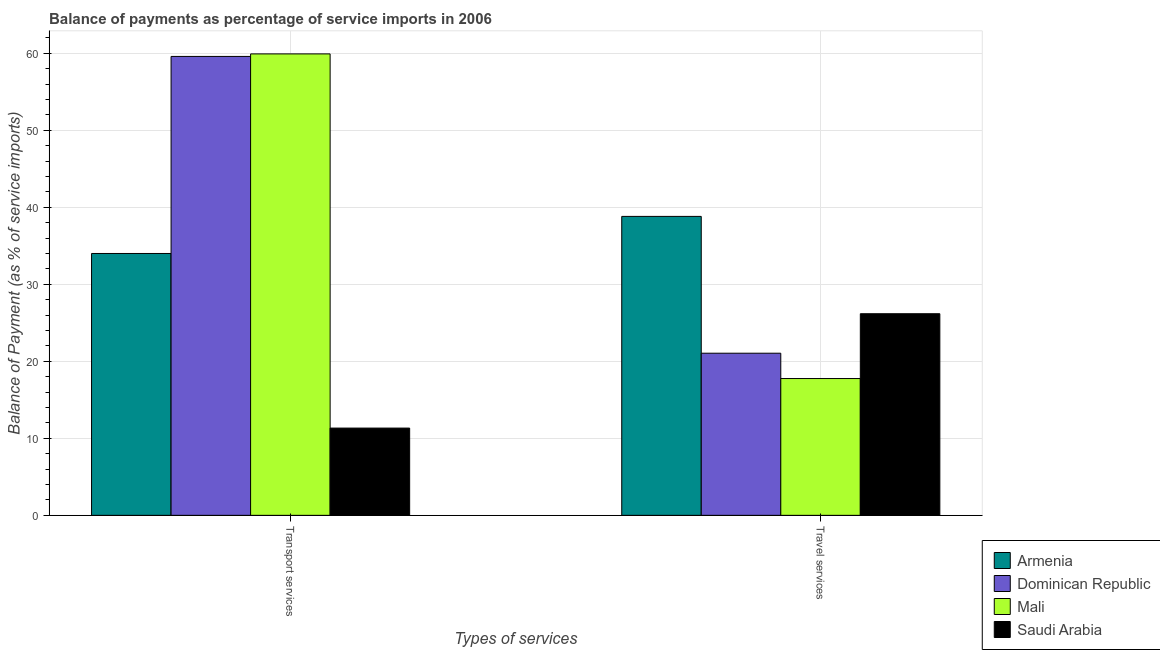How many different coloured bars are there?
Offer a very short reply. 4. Are the number of bars on each tick of the X-axis equal?
Offer a terse response. Yes. How many bars are there on the 2nd tick from the left?
Your answer should be very brief. 4. What is the label of the 1st group of bars from the left?
Provide a succinct answer. Transport services. What is the balance of payments of transport services in Mali?
Your answer should be compact. 59.91. Across all countries, what is the maximum balance of payments of transport services?
Your response must be concise. 59.91. Across all countries, what is the minimum balance of payments of travel services?
Provide a succinct answer. 17.76. In which country was the balance of payments of travel services maximum?
Provide a short and direct response. Armenia. In which country was the balance of payments of transport services minimum?
Ensure brevity in your answer.  Saudi Arabia. What is the total balance of payments of travel services in the graph?
Give a very brief answer. 103.8. What is the difference between the balance of payments of travel services in Armenia and that in Saudi Arabia?
Your response must be concise. 12.64. What is the difference between the balance of payments of transport services in Dominican Republic and the balance of payments of travel services in Saudi Arabia?
Make the answer very short. 33.41. What is the average balance of payments of travel services per country?
Your response must be concise. 25.95. What is the difference between the balance of payments of transport services and balance of payments of travel services in Mali?
Provide a succinct answer. 42.15. What is the ratio of the balance of payments of transport services in Mali to that in Armenia?
Make the answer very short. 1.76. What does the 3rd bar from the left in Travel services represents?
Your answer should be very brief. Mali. What does the 4th bar from the right in Travel services represents?
Your answer should be very brief. Armenia. How many bars are there?
Provide a short and direct response. 8. What is the difference between two consecutive major ticks on the Y-axis?
Keep it short and to the point. 10. Does the graph contain any zero values?
Your answer should be very brief. No. Where does the legend appear in the graph?
Offer a very short reply. Bottom right. How many legend labels are there?
Your response must be concise. 4. What is the title of the graph?
Keep it short and to the point. Balance of payments as percentage of service imports in 2006. Does "European Union" appear as one of the legend labels in the graph?
Your answer should be compact. No. What is the label or title of the X-axis?
Provide a short and direct response. Types of services. What is the label or title of the Y-axis?
Your answer should be compact. Balance of Payment (as % of service imports). What is the Balance of Payment (as % of service imports) of Armenia in Transport services?
Make the answer very short. 34. What is the Balance of Payment (as % of service imports) in Dominican Republic in Transport services?
Ensure brevity in your answer.  59.58. What is the Balance of Payment (as % of service imports) in Mali in Transport services?
Ensure brevity in your answer.  59.91. What is the Balance of Payment (as % of service imports) of Saudi Arabia in Transport services?
Keep it short and to the point. 11.33. What is the Balance of Payment (as % of service imports) of Armenia in Travel services?
Your response must be concise. 38.81. What is the Balance of Payment (as % of service imports) in Dominican Republic in Travel services?
Offer a terse response. 21.05. What is the Balance of Payment (as % of service imports) of Mali in Travel services?
Offer a very short reply. 17.76. What is the Balance of Payment (as % of service imports) in Saudi Arabia in Travel services?
Give a very brief answer. 26.18. Across all Types of services, what is the maximum Balance of Payment (as % of service imports) of Armenia?
Your answer should be very brief. 38.81. Across all Types of services, what is the maximum Balance of Payment (as % of service imports) in Dominican Republic?
Your answer should be very brief. 59.58. Across all Types of services, what is the maximum Balance of Payment (as % of service imports) of Mali?
Ensure brevity in your answer.  59.91. Across all Types of services, what is the maximum Balance of Payment (as % of service imports) in Saudi Arabia?
Provide a succinct answer. 26.18. Across all Types of services, what is the minimum Balance of Payment (as % of service imports) in Armenia?
Your answer should be compact. 34. Across all Types of services, what is the minimum Balance of Payment (as % of service imports) of Dominican Republic?
Keep it short and to the point. 21.05. Across all Types of services, what is the minimum Balance of Payment (as % of service imports) of Mali?
Provide a short and direct response. 17.76. Across all Types of services, what is the minimum Balance of Payment (as % of service imports) in Saudi Arabia?
Offer a terse response. 11.33. What is the total Balance of Payment (as % of service imports) of Armenia in the graph?
Offer a very short reply. 72.81. What is the total Balance of Payment (as % of service imports) in Dominican Republic in the graph?
Your answer should be very brief. 80.63. What is the total Balance of Payment (as % of service imports) of Mali in the graph?
Your answer should be very brief. 77.67. What is the total Balance of Payment (as % of service imports) in Saudi Arabia in the graph?
Your answer should be compact. 37.51. What is the difference between the Balance of Payment (as % of service imports) of Armenia in Transport services and that in Travel services?
Provide a short and direct response. -4.81. What is the difference between the Balance of Payment (as % of service imports) in Dominican Republic in Transport services and that in Travel services?
Your answer should be compact. 38.53. What is the difference between the Balance of Payment (as % of service imports) in Mali in Transport services and that in Travel services?
Ensure brevity in your answer.  42.15. What is the difference between the Balance of Payment (as % of service imports) in Saudi Arabia in Transport services and that in Travel services?
Make the answer very short. -14.85. What is the difference between the Balance of Payment (as % of service imports) in Armenia in Transport services and the Balance of Payment (as % of service imports) in Dominican Republic in Travel services?
Keep it short and to the point. 12.95. What is the difference between the Balance of Payment (as % of service imports) of Armenia in Transport services and the Balance of Payment (as % of service imports) of Mali in Travel services?
Your answer should be very brief. 16.24. What is the difference between the Balance of Payment (as % of service imports) in Armenia in Transport services and the Balance of Payment (as % of service imports) in Saudi Arabia in Travel services?
Provide a short and direct response. 7.82. What is the difference between the Balance of Payment (as % of service imports) in Dominican Republic in Transport services and the Balance of Payment (as % of service imports) in Mali in Travel services?
Give a very brief answer. 41.82. What is the difference between the Balance of Payment (as % of service imports) in Dominican Republic in Transport services and the Balance of Payment (as % of service imports) in Saudi Arabia in Travel services?
Offer a terse response. 33.41. What is the difference between the Balance of Payment (as % of service imports) of Mali in Transport services and the Balance of Payment (as % of service imports) of Saudi Arabia in Travel services?
Provide a short and direct response. 33.73. What is the average Balance of Payment (as % of service imports) in Armenia per Types of services?
Offer a very short reply. 36.41. What is the average Balance of Payment (as % of service imports) in Dominican Republic per Types of services?
Your answer should be very brief. 40.32. What is the average Balance of Payment (as % of service imports) of Mali per Types of services?
Make the answer very short. 38.84. What is the average Balance of Payment (as % of service imports) in Saudi Arabia per Types of services?
Make the answer very short. 18.75. What is the difference between the Balance of Payment (as % of service imports) of Armenia and Balance of Payment (as % of service imports) of Dominican Republic in Transport services?
Your response must be concise. -25.58. What is the difference between the Balance of Payment (as % of service imports) in Armenia and Balance of Payment (as % of service imports) in Mali in Transport services?
Your answer should be compact. -25.91. What is the difference between the Balance of Payment (as % of service imports) of Armenia and Balance of Payment (as % of service imports) of Saudi Arabia in Transport services?
Your answer should be very brief. 22.67. What is the difference between the Balance of Payment (as % of service imports) of Dominican Republic and Balance of Payment (as % of service imports) of Mali in Transport services?
Your answer should be very brief. -0.33. What is the difference between the Balance of Payment (as % of service imports) in Dominican Republic and Balance of Payment (as % of service imports) in Saudi Arabia in Transport services?
Your answer should be compact. 48.25. What is the difference between the Balance of Payment (as % of service imports) in Mali and Balance of Payment (as % of service imports) in Saudi Arabia in Transport services?
Your answer should be compact. 48.58. What is the difference between the Balance of Payment (as % of service imports) of Armenia and Balance of Payment (as % of service imports) of Dominican Republic in Travel services?
Provide a short and direct response. 17.76. What is the difference between the Balance of Payment (as % of service imports) of Armenia and Balance of Payment (as % of service imports) of Mali in Travel services?
Provide a succinct answer. 21.05. What is the difference between the Balance of Payment (as % of service imports) of Armenia and Balance of Payment (as % of service imports) of Saudi Arabia in Travel services?
Offer a terse response. 12.64. What is the difference between the Balance of Payment (as % of service imports) of Dominican Republic and Balance of Payment (as % of service imports) of Mali in Travel services?
Make the answer very short. 3.29. What is the difference between the Balance of Payment (as % of service imports) in Dominican Republic and Balance of Payment (as % of service imports) in Saudi Arabia in Travel services?
Provide a short and direct response. -5.13. What is the difference between the Balance of Payment (as % of service imports) in Mali and Balance of Payment (as % of service imports) in Saudi Arabia in Travel services?
Your answer should be compact. -8.41. What is the ratio of the Balance of Payment (as % of service imports) of Armenia in Transport services to that in Travel services?
Make the answer very short. 0.88. What is the ratio of the Balance of Payment (as % of service imports) in Dominican Republic in Transport services to that in Travel services?
Keep it short and to the point. 2.83. What is the ratio of the Balance of Payment (as % of service imports) in Mali in Transport services to that in Travel services?
Provide a short and direct response. 3.37. What is the ratio of the Balance of Payment (as % of service imports) in Saudi Arabia in Transport services to that in Travel services?
Your answer should be very brief. 0.43. What is the difference between the highest and the second highest Balance of Payment (as % of service imports) in Armenia?
Your response must be concise. 4.81. What is the difference between the highest and the second highest Balance of Payment (as % of service imports) of Dominican Republic?
Your answer should be very brief. 38.53. What is the difference between the highest and the second highest Balance of Payment (as % of service imports) of Mali?
Offer a very short reply. 42.15. What is the difference between the highest and the second highest Balance of Payment (as % of service imports) in Saudi Arabia?
Your answer should be very brief. 14.85. What is the difference between the highest and the lowest Balance of Payment (as % of service imports) of Armenia?
Provide a short and direct response. 4.81. What is the difference between the highest and the lowest Balance of Payment (as % of service imports) in Dominican Republic?
Ensure brevity in your answer.  38.53. What is the difference between the highest and the lowest Balance of Payment (as % of service imports) in Mali?
Your response must be concise. 42.15. What is the difference between the highest and the lowest Balance of Payment (as % of service imports) in Saudi Arabia?
Your response must be concise. 14.85. 